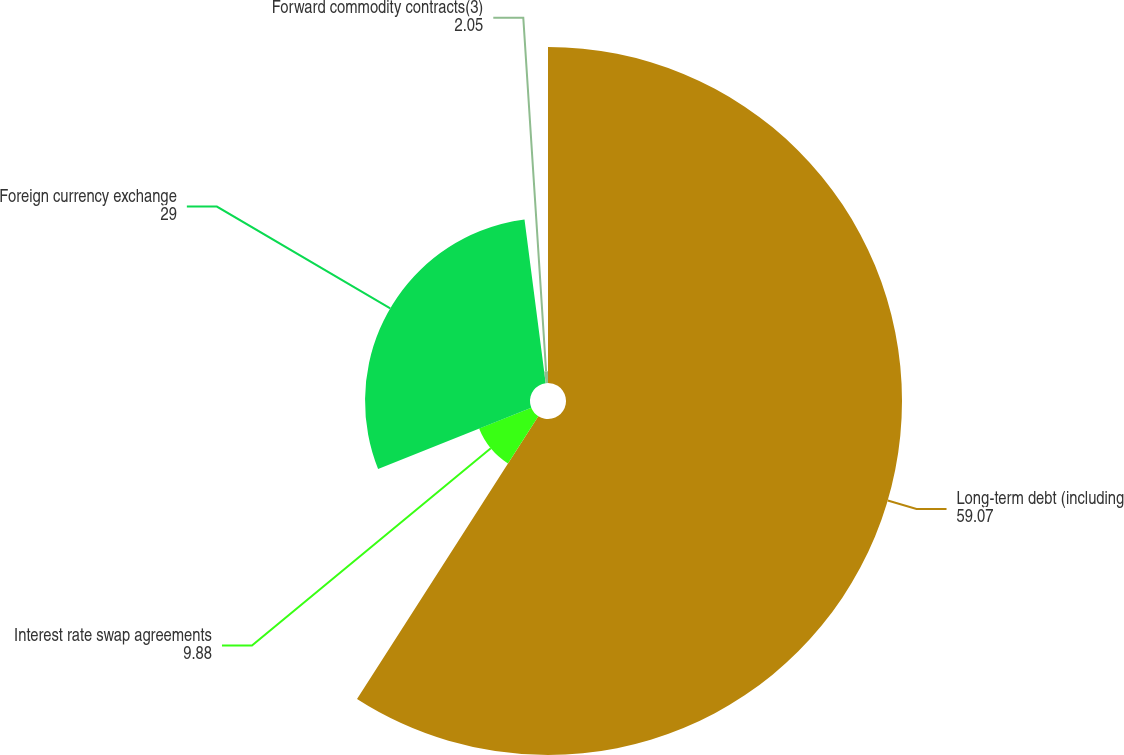<chart> <loc_0><loc_0><loc_500><loc_500><pie_chart><fcel>Long-term debt (including<fcel>Interest rate swap agreements<fcel>Foreign currency exchange<fcel>Forward commodity contracts(3)<nl><fcel>59.07%<fcel>9.88%<fcel>29.0%<fcel>2.05%<nl></chart> 